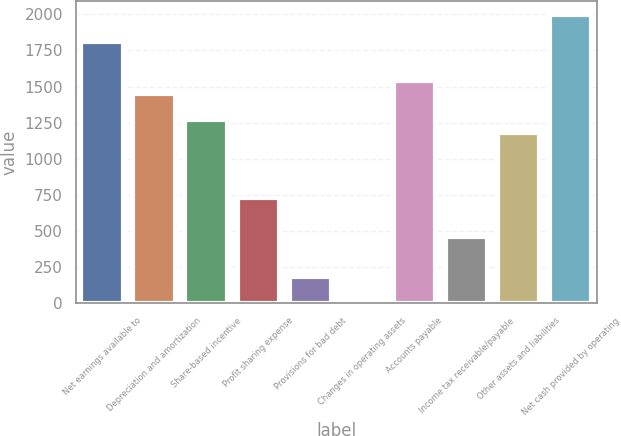<chart> <loc_0><loc_0><loc_500><loc_500><bar_chart><fcel>Net earnings available to<fcel>Depreciation and amortization<fcel>Share-based incentive<fcel>Profit sharing expense<fcel>Provisions for bad debt<fcel>Changes in operating assets<fcel>Accounts payable<fcel>Income tax receivable/payable<fcel>Other assets and liabilities<fcel>Net cash provided by operating<nl><fcel>1811.2<fcel>1449.48<fcel>1268.62<fcel>726.04<fcel>183.46<fcel>2.6<fcel>1539.91<fcel>454.75<fcel>1178.19<fcel>1992.06<nl></chart> 